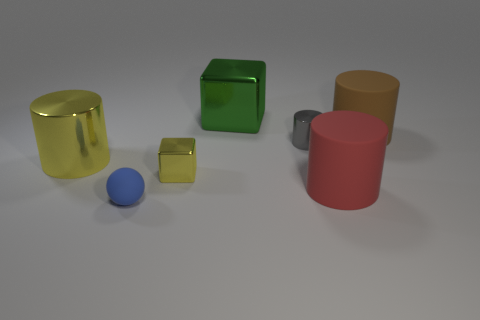Add 2 balls. How many objects exist? 9 Subtract all cubes. How many objects are left? 5 Subtract all large yellow cylinders. Subtract all tiny gray objects. How many objects are left? 5 Add 4 blue rubber balls. How many blue rubber balls are left? 5 Add 2 small blue matte things. How many small blue matte things exist? 3 Subtract 0 red cubes. How many objects are left? 7 